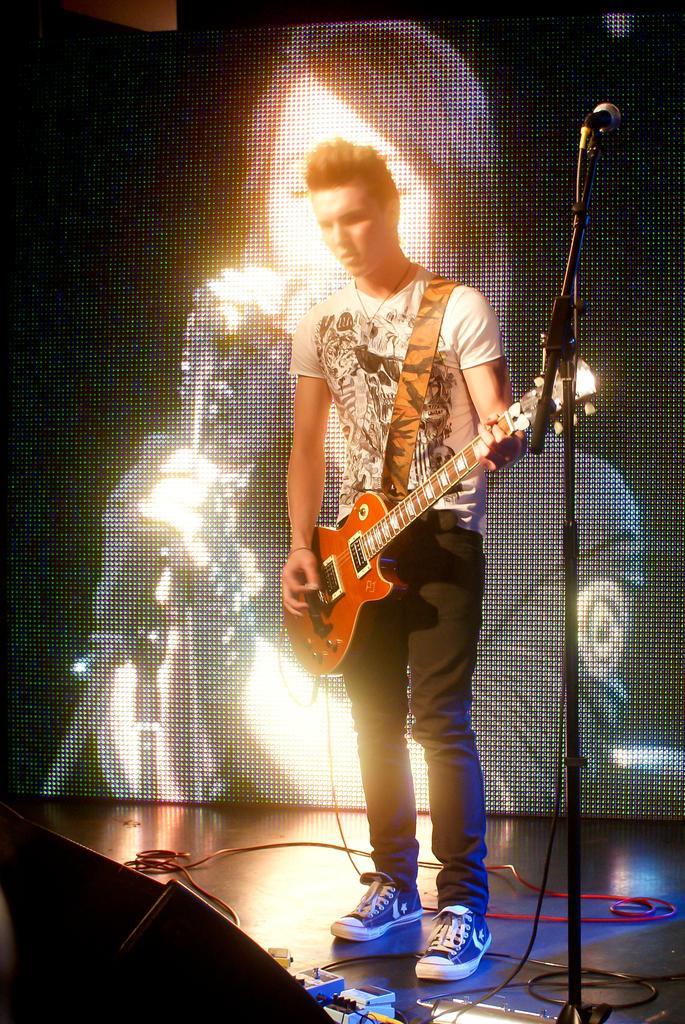Could you give a brief overview of what you see in this image? In this picture a man is playing guitar in front of microphone, in the background we can see couple of cables and a projector screen. 